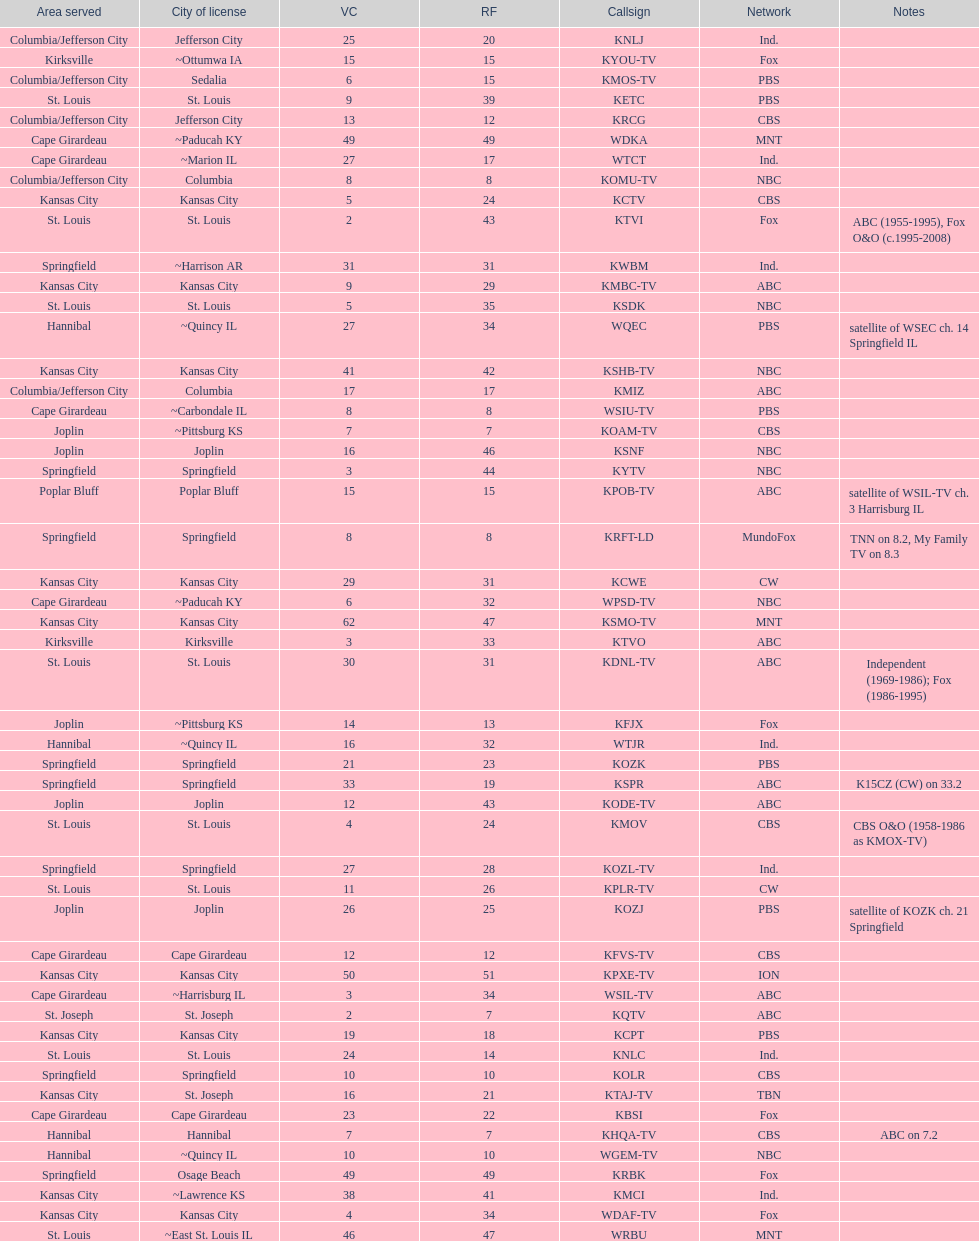Kode-tv and wsil-tv both are a part of which network? ABC. 